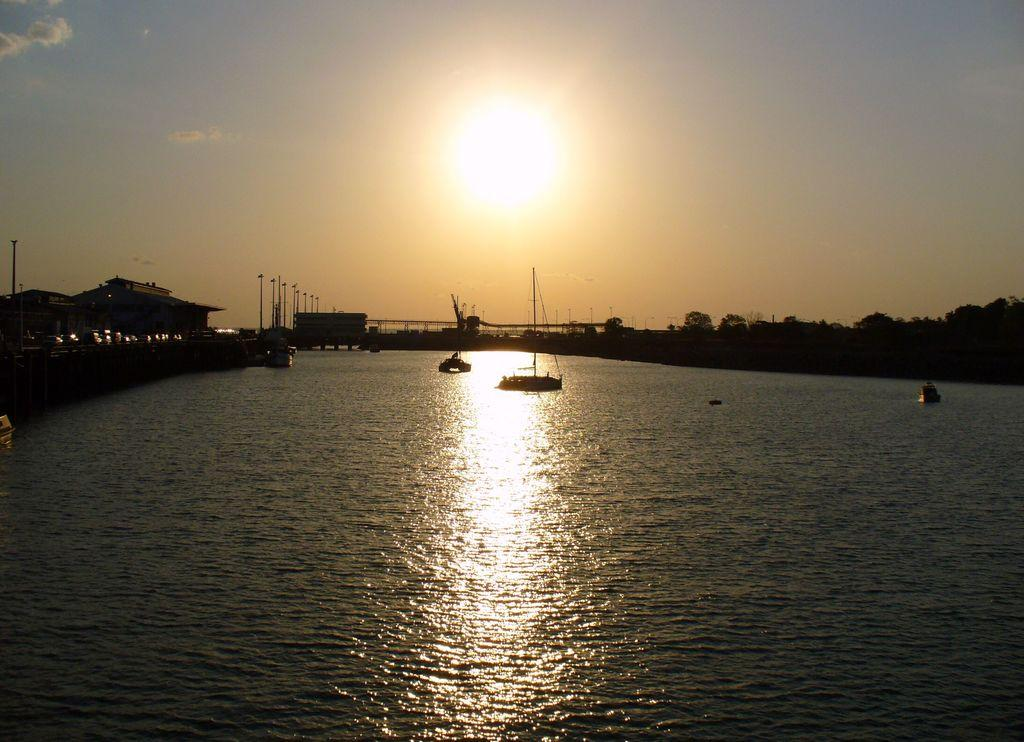What is the main subject of the image? The main subject of the image is boats. Where are the boats located? The boats are on the water. What can be seen in the background of the image? There are buildings, trees, and the sky visible in the background of the image. Can the sun be seen in the image? Yes, the sun is observable in the sky. What arithmetic problem is the stranger solving on the tray in the image? There is no stranger or tray present in the image, and therefore no arithmetic problem can be observed. 